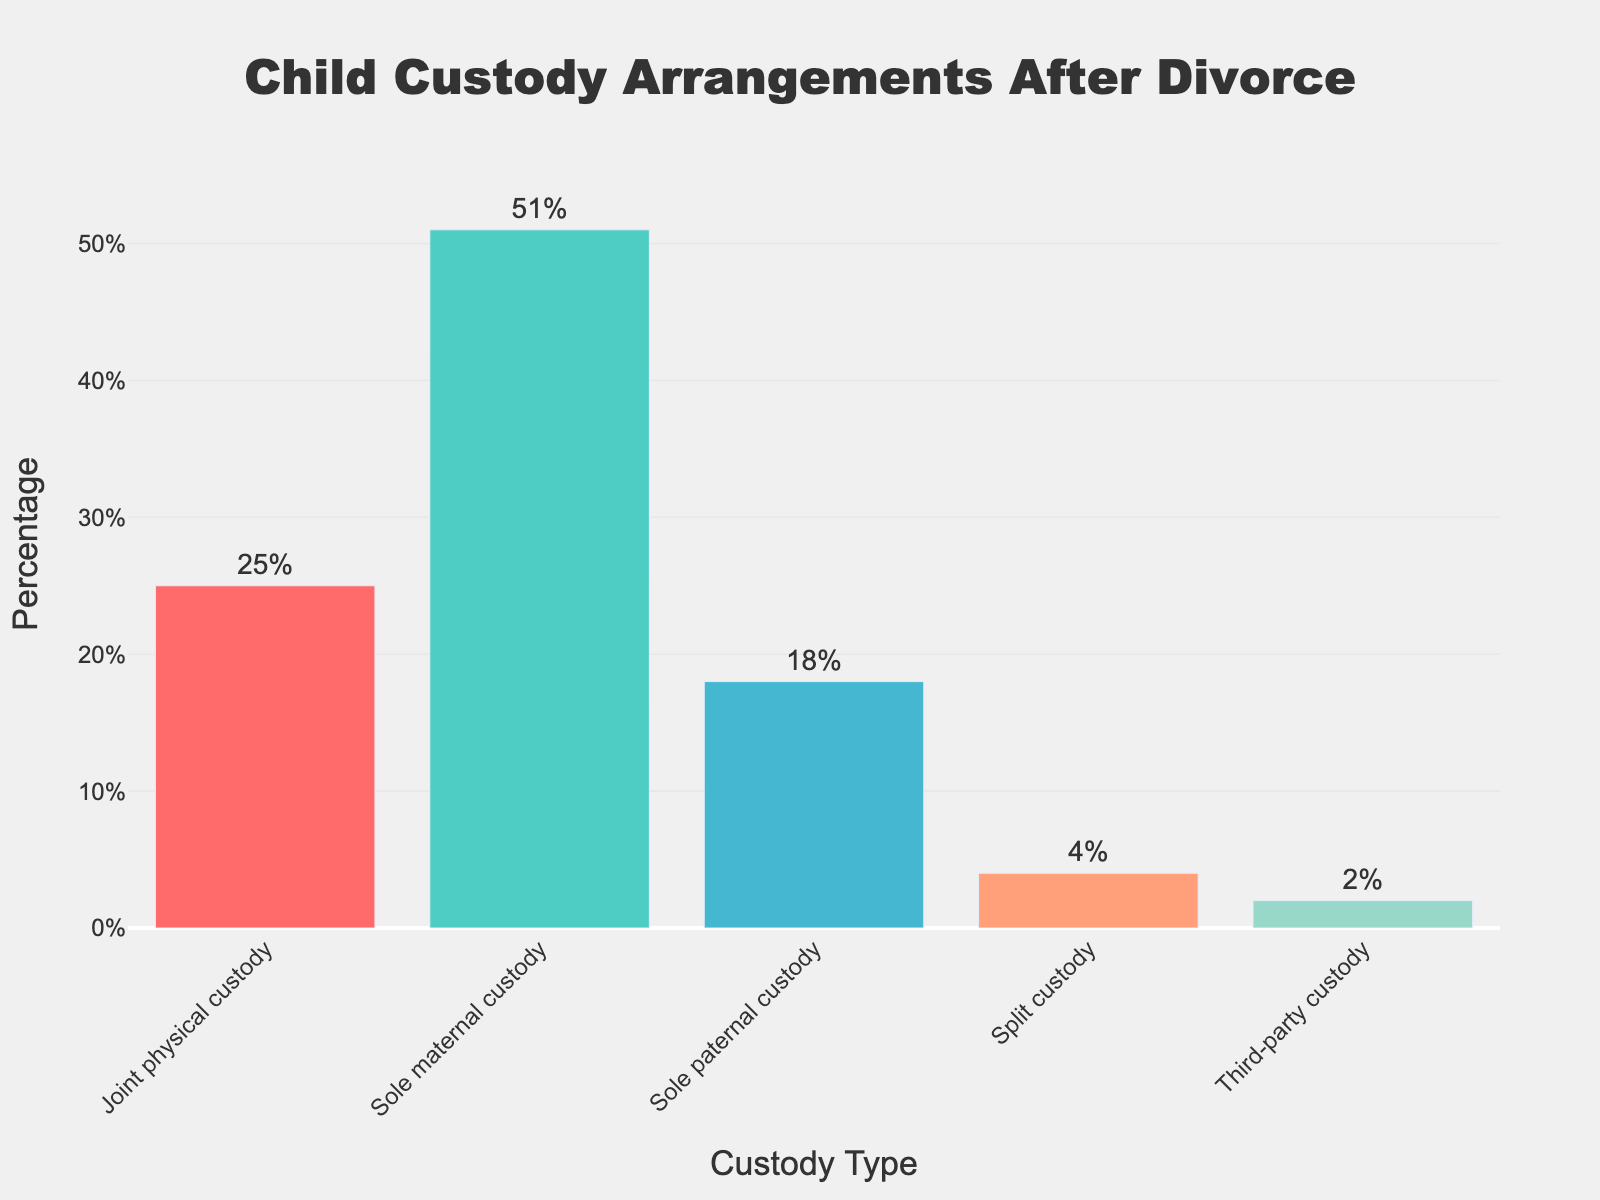Which type of child custody arrangement is the most common? The most common type of child custody arrangement is represented by the tallest bar in the chart. The bar labeled 'Sole maternal custody' is the tallest.
Answer: Sole maternal custody Which type of child custody arrangement is the least common? The least common type of child custody arrangement is represented by the shortest bar in the chart. The bar labeled 'Third-party custody' is the shortest.
Answer: Third-party custody How much higher is the percentage of 'Sole maternal custody' compared to 'Joint physical custody'? To find the difference, subtract the percentage of 'Joint physical custody' (25%) from 'Sole maternal custody' (51%).
Answer: 26% What is the sum of the percentages of 'Split custody' and 'Third-party custody'? To find the sum, add the percentage of 'Split custody' (4%) to the percentage of 'Third-party custody' (2%).
Answer: 6% Which two types of custody arrangements together make up less than 10%? 'Split custody' (4%) and 'Third-party custody' (2%) together make up 4% + 2%, which is less than 10%.
Answer: Split custody and Third-party custody What is the combined percentage of 'Sole maternal custody' and 'Sole paternal custody'? To find the combined percentage, add the percentage of 'Sole maternal custody' (51%) to the percentage of 'Sole paternal custody' (18%).
Answer: 69% By how much does 'Sole maternal custody' exceed 'Sole paternal custody'? To find the excess percentage, subtract 'Sole paternal custody' (18%) from 'Sole maternal custody' (51%).
Answer: 33% Which custody type has the closest percentage to 'Joint physical custody'? Comparing the percentages visually, 'Sole paternal custody' at 18% is closest to 'Joint physical custody' at 25%.
Answer: Sole paternal custody Which color represents 'Joint physical custody'? The color of the bar representing 'Joint physical custody' can be identified by observing the color of the respective bar in the chart.
Answer: Red 